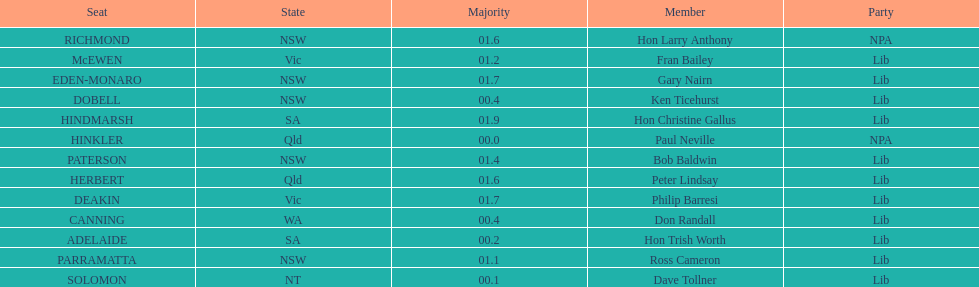What was the total majority that the dobell seat had? 00.4. 